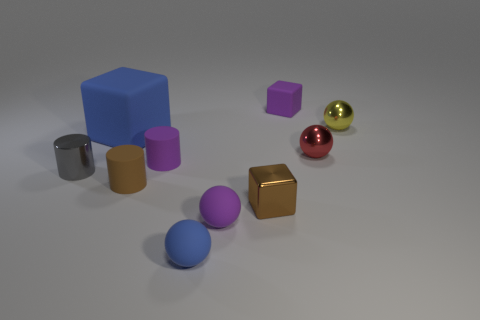Subtract all balls. How many objects are left? 6 Add 8 purple balls. How many purple balls are left? 9 Add 5 gray things. How many gray things exist? 6 Subtract 0 green blocks. How many objects are left? 10 Subtract all purple rubber cylinders. Subtract all small green metallic things. How many objects are left? 9 